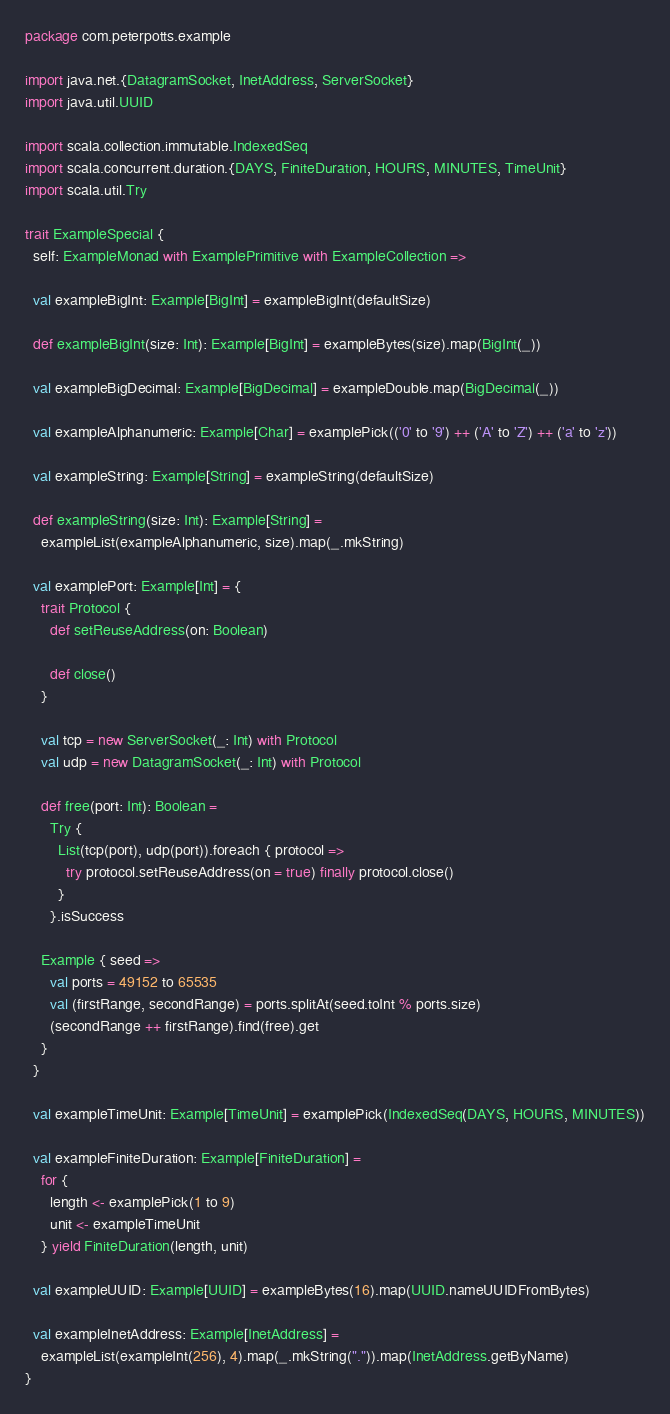<code> <loc_0><loc_0><loc_500><loc_500><_Scala_>package com.peterpotts.example

import java.net.{DatagramSocket, InetAddress, ServerSocket}
import java.util.UUID

import scala.collection.immutable.IndexedSeq
import scala.concurrent.duration.{DAYS, FiniteDuration, HOURS, MINUTES, TimeUnit}
import scala.util.Try

trait ExampleSpecial {
  self: ExampleMonad with ExamplePrimitive with ExampleCollection =>

  val exampleBigInt: Example[BigInt] = exampleBigInt(defaultSize)

  def exampleBigInt(size: Int): Example[BigInt] = exampleBytes(size).map(BigInt(_))

  val exampleBigDecimal: Example[BigDecimal] = exampleDouble.map(BigDecimal(_))

  val exampleAlphanumeric: Example[Char] = examplePick(('0' to '9') ++ ('A' to 'Z') ++ ('a' to 'z'))

  val exampleString: Example[String] = exampleString(defaultSize)

  def exampleString(size: Int): Example[String] =
    exampleList(exampleAlphanumeric, size).map(_.mkString)

  val examplePort: Example[Int] = {
    trait Protocol {
      def setReuseAddress(on: Boolean)

      def close()
    }

    val tcp = new ServerSocket(_: Int) with Protocol
    val udp = new DatagramSocket(_: Int) with Protocol

    def free(port: Int): Boolean =
      Try {
        List(tcp(port), udp(port)).foreach { protocol =>
          try protocol.setReuseAddress(on = true) finally protocol.close()
        }
      }.isSuccess

    Example { seed =>
      val ports = 49152 to 65535
      val (firstRange, secondRange) = ports.splitAt(seed.toInt % ports.size)
      (secondRange ++ firstRange).find(free).get
    }
  }

  val exampleTimeUnit: Example[TimeUnit] = examplePick(IndexedSeq(DAYS, HOURS, MINUTES))

  val exampleFiniteDuration: Example[FiniteDuration] =
    for {
      length <- examplePick(1 to 9)
      unit <- exampleTimeUnit
    } yield FiniteDuration(length, unit)

  val exampleUUID: Example[UUID] = exampleBytes(16).map(UUID.nameUUIDFromBytes)

  val exampleInetAddress: Example[InetAddress] =
    exampleList(exampleInt(256), 4).map(_.mkString(".")).map(InetAddress.getByName)
}
</code> 